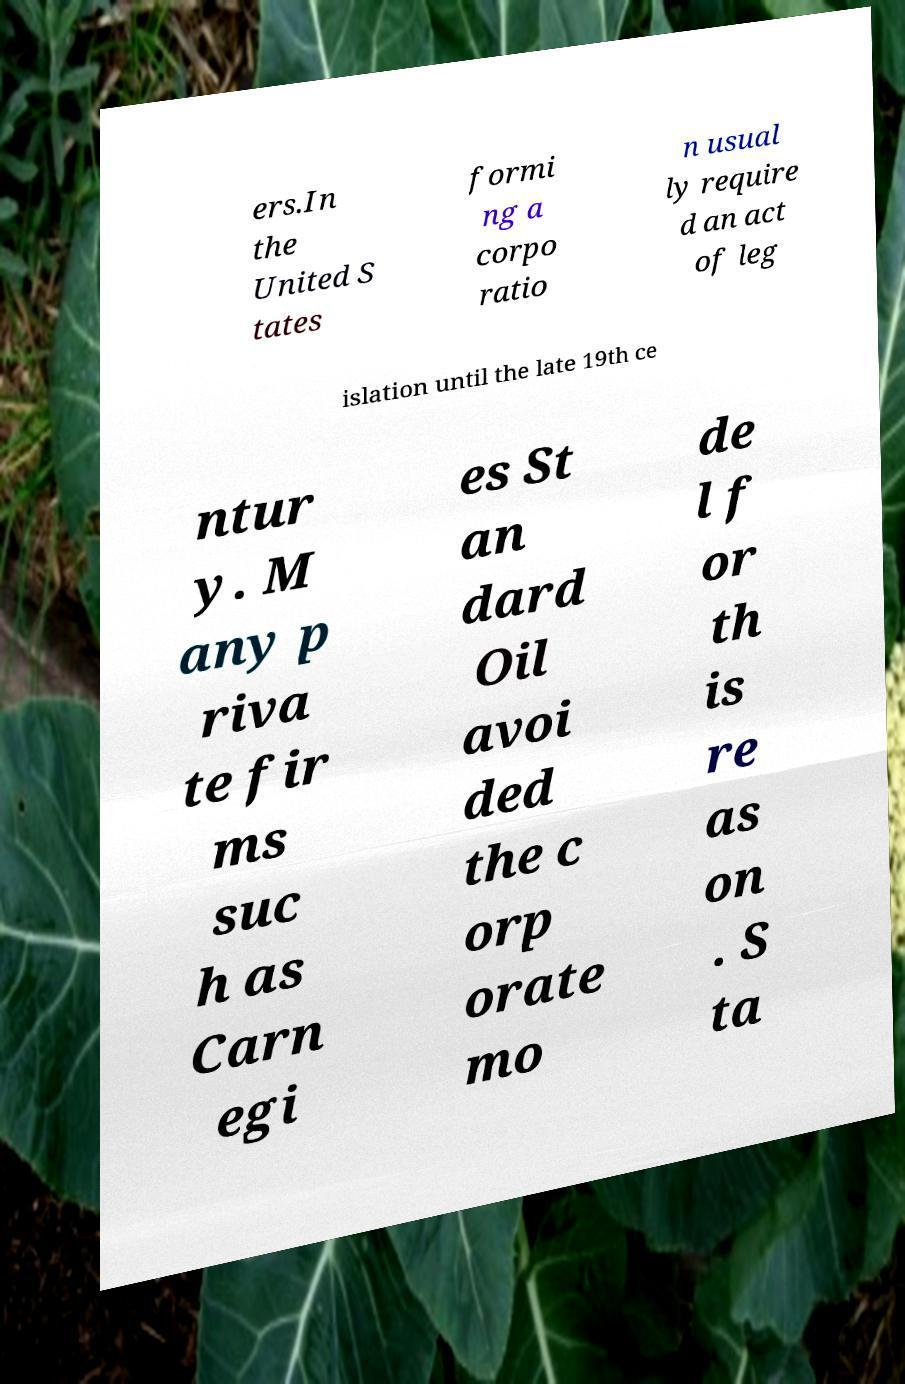Can you read and provide the text displayed in the image?This photo seems to have some interesting text. Can you extract and type it out for me? ers.In the United S tates formi ng a corpo ratio n usual ly require d an act of leg islation until the late 19th ce ntur y. M any p riva te fir ms suc h as Carn egi es St an dard Oil avoi ded the c orp orate mo de l f or th is re as on . S ta 